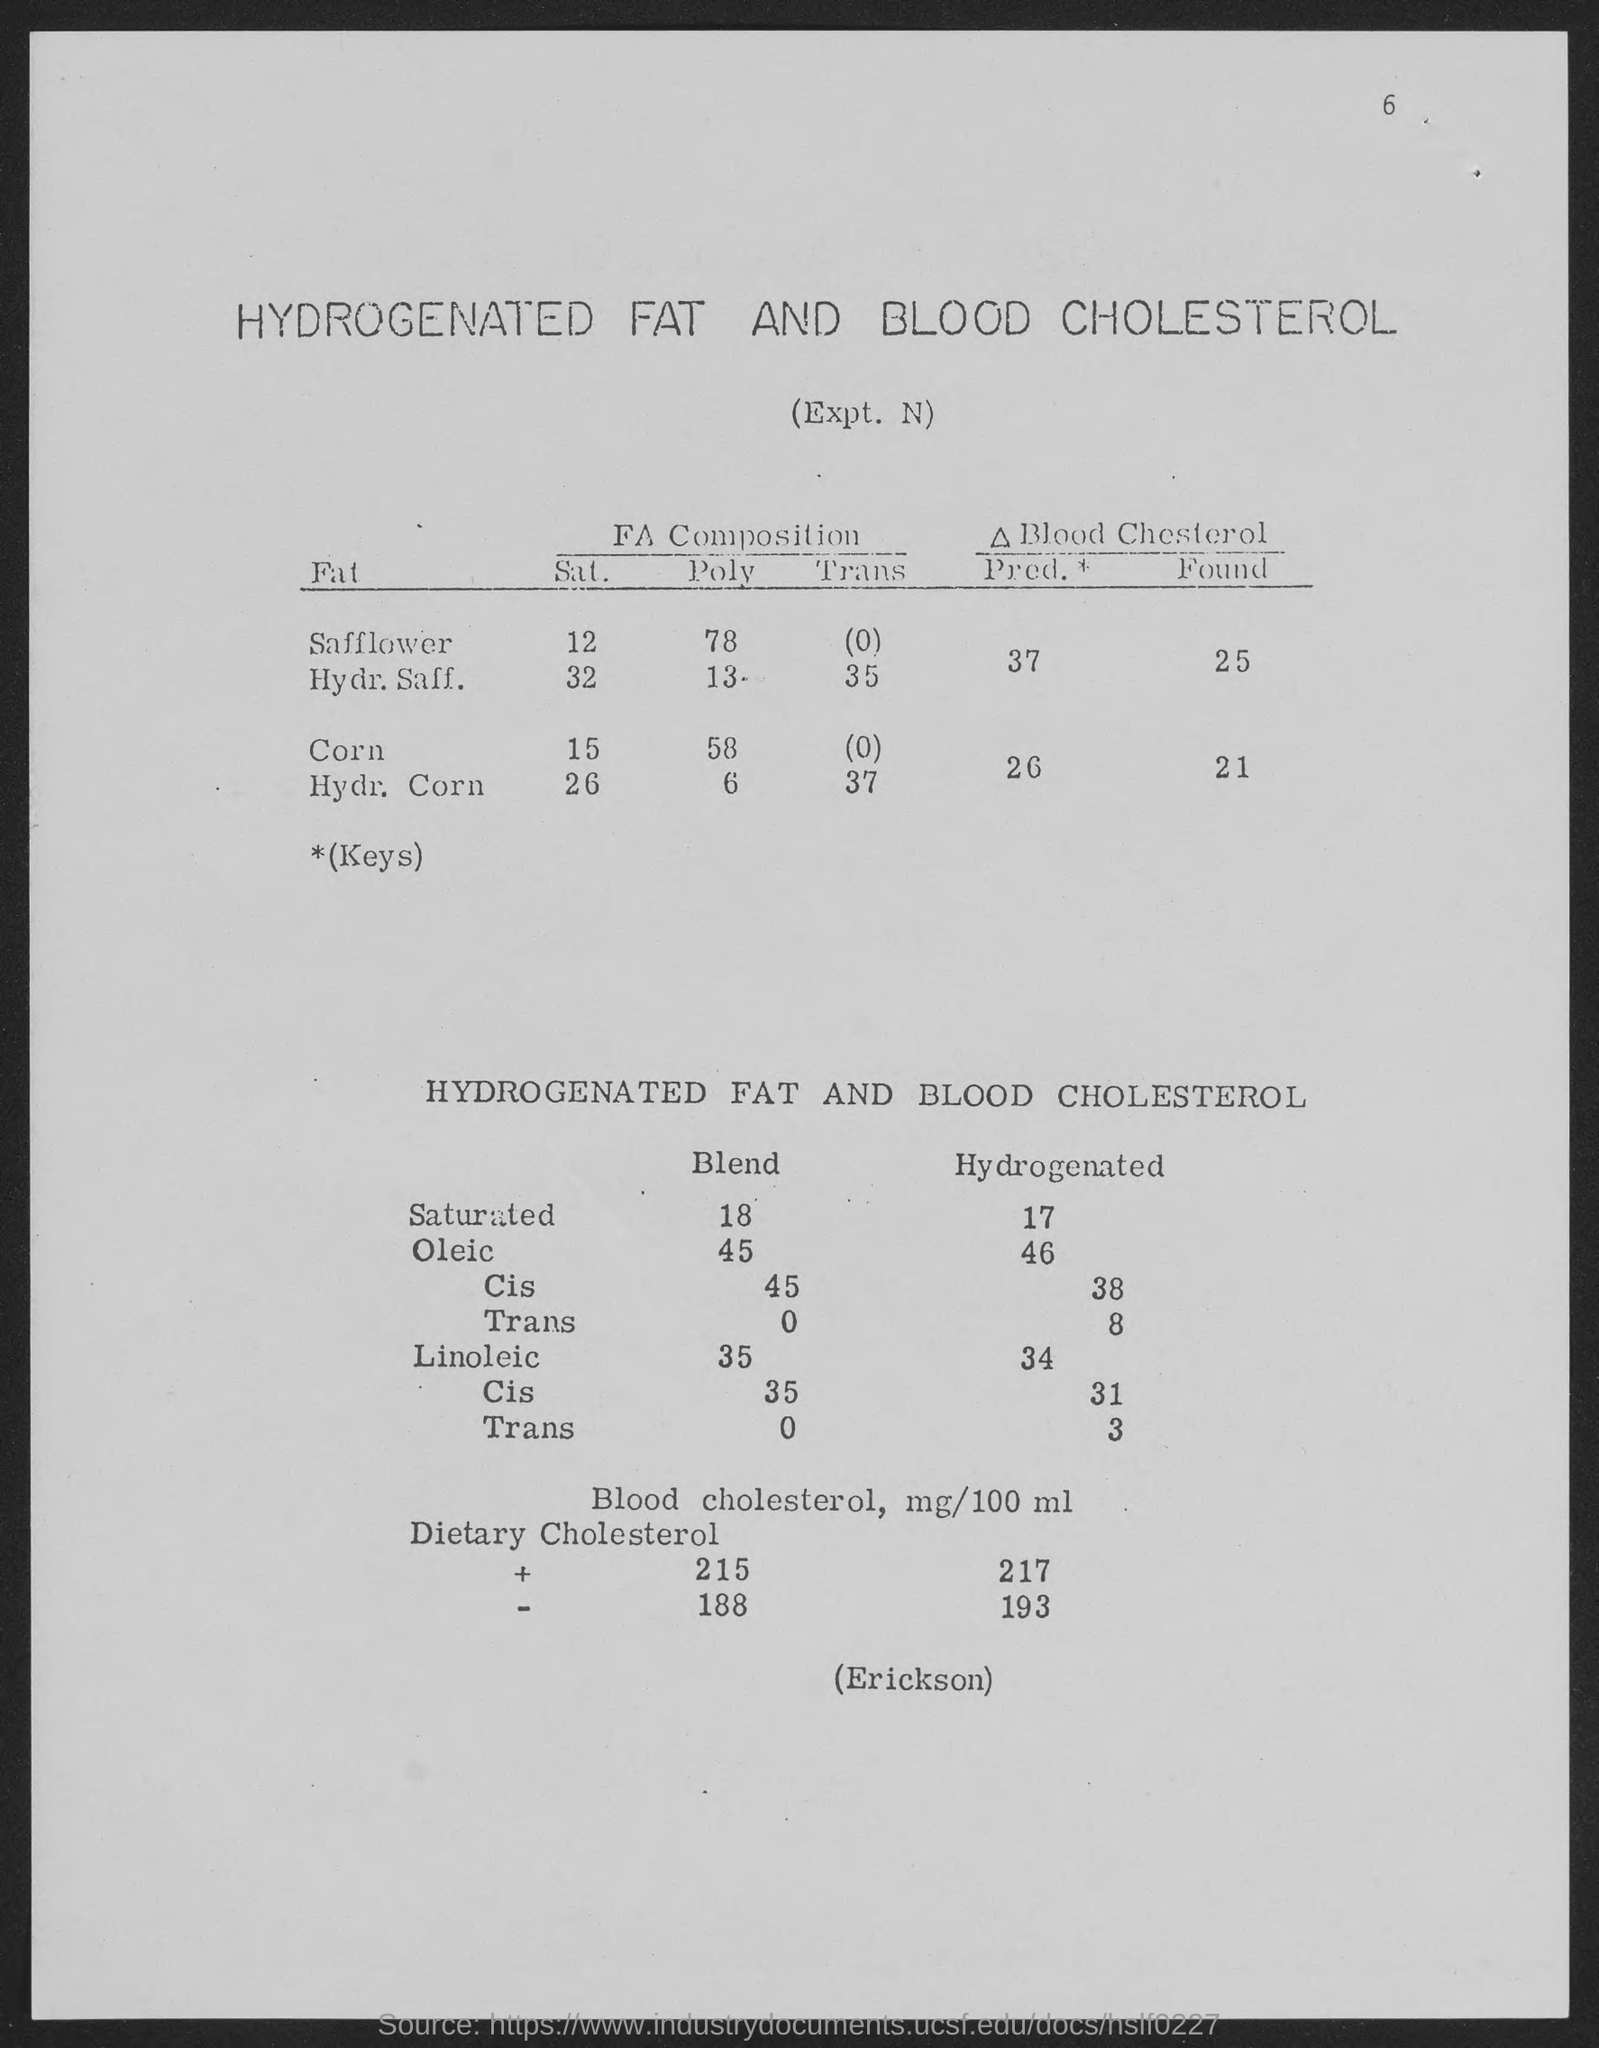List a handful of essential elements in this visual. The number at the top-right corner of the page is 6. 